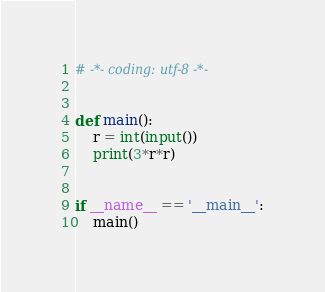<code> <loc_0><loc_0><loc_500><loc_500><_Python_># -*- coding: utf-8 -*-


def main():
    r = int(input())
    print(3*r*r)


if __name__ == '__main__':
    main()
</code> 